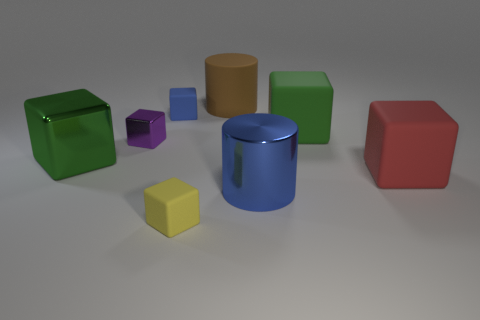Which shapes in the image have no visible shadows? In this image, every object has a subtle shadow due to the lighting, which suggests a soft and diffused light source. However, the shadows might appear less distinct on brightly-colored objects. 